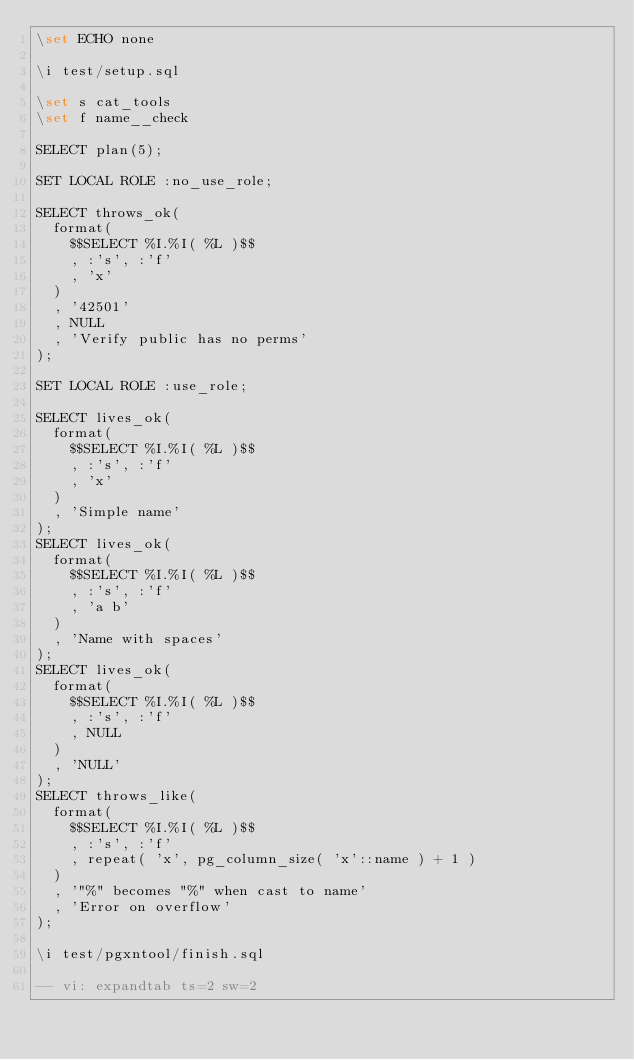<code> <loc_0><loc_0><loc_500><loc_500><_SQL_>\set ECHO none

\i test/setup.sql

\set s cat_tools
\set f name__check

SELECT plan(5);

SET LOCAL ROLE :no_use_role;

SELECT throws_ok(
  format(
    $$SELECT %I.%I( %L )$$
    , :'s', :'f'
    , 'x'
  )
  , '42501'
  , NULL
  , 'Verify public has no perms'
);

SET LOCAL ROLE :use_role;

SELECT lives_ok(
  format(
    $$SELECT %I.%I( %L )$$
    , :'s', :'f'
    , 'x'
  )
  , 'Simple name'
);
SELECT lives_ok(
  format(
    $$SELECT %I.%I( %L )$$
    , :'s', :'f'
    , 'a b'
  )
  , 'Name with spaces'
);
SELECT lives_ok(
  format(
    $$SELECT %I.%I( %L )$$
    , :'s', :'f'
    , NULL
  )
  , 'NULL'
);
SELECT throws_like(
  format(
    $$SELECT %I.%I( %L )$$
    , :'s', :'f'
    , repeat( 'x', pg_column_size( 'x'::name ) + 1 )
  )
  , '"%" becomes "%" when cast to name'
  , 'Error on overflow'
);

\i test/pgxntool/finish.sql

-- vi: expandtab ts=2 sw=2
</code> 